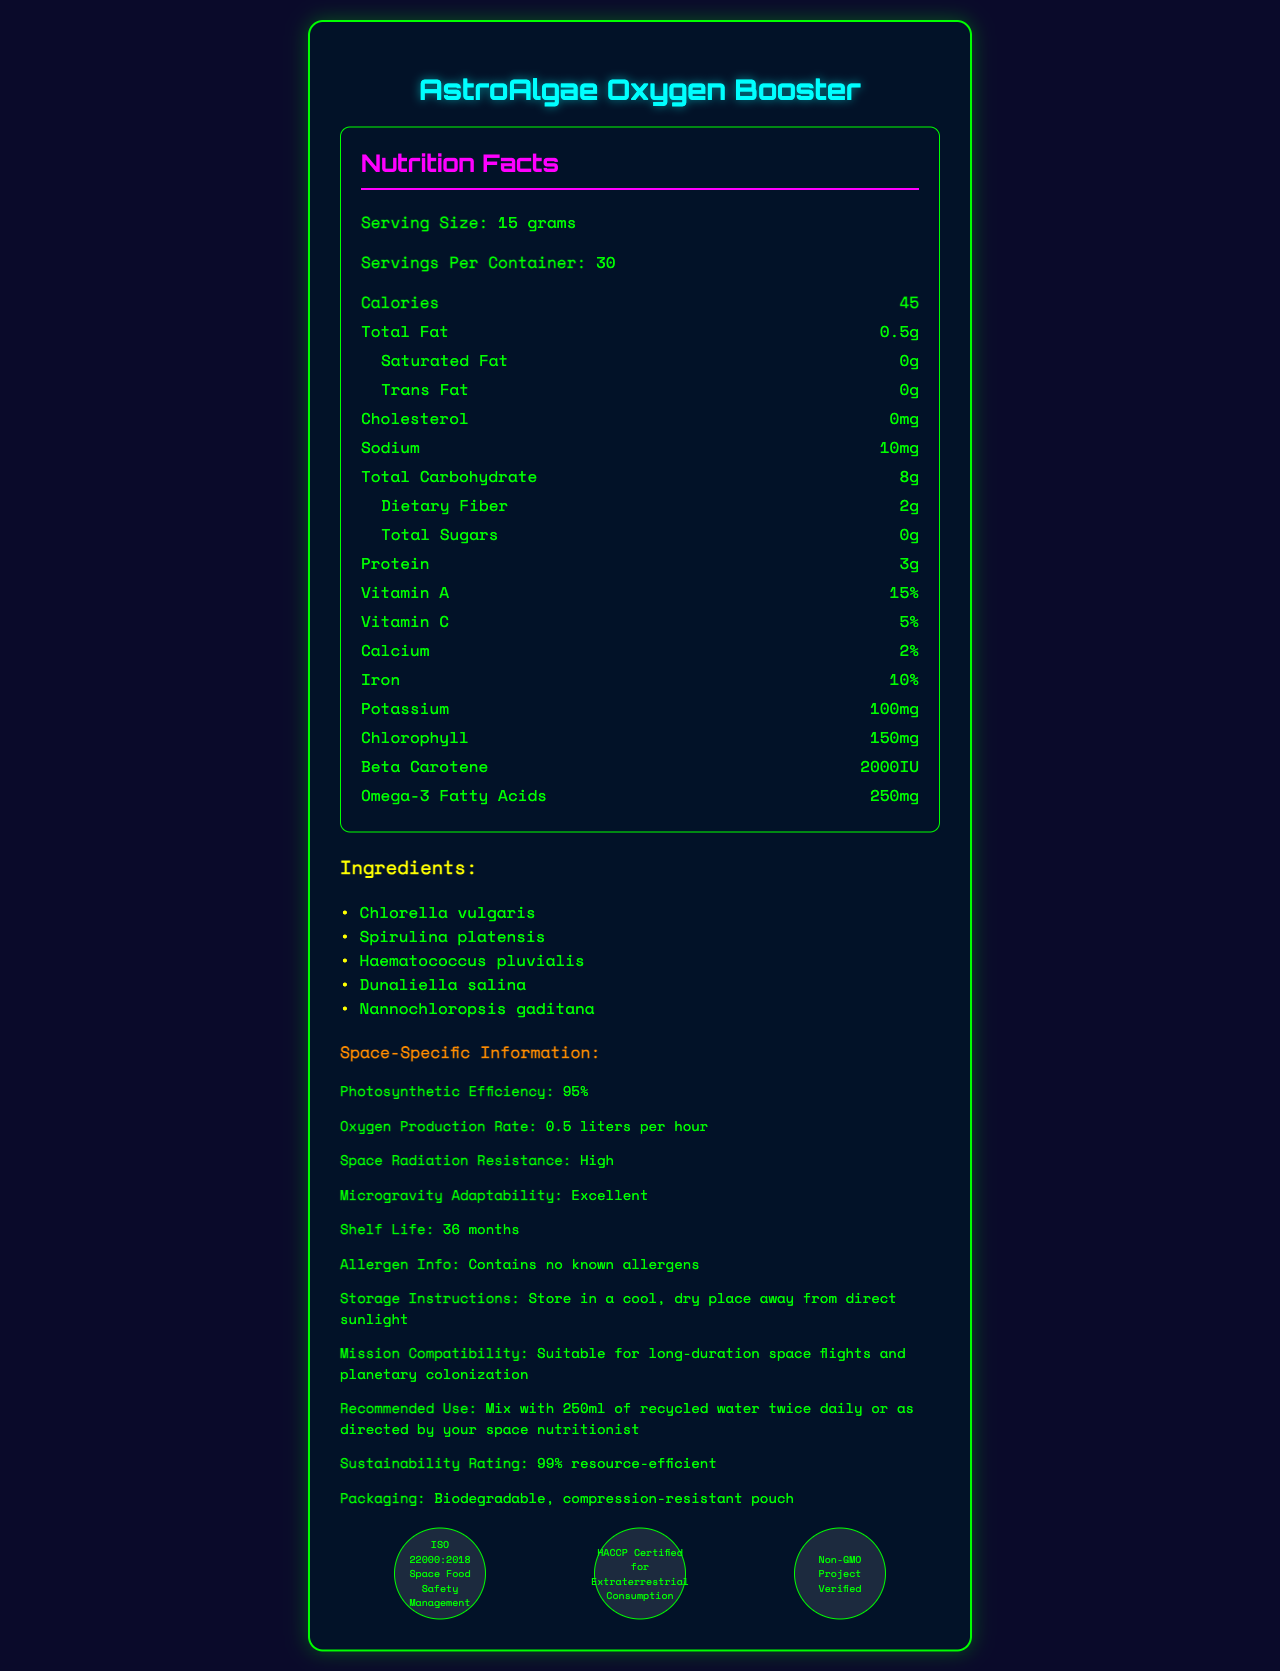What is the serving size of the AstroAlgae Oxygen Booster? The document lists the serving size as 15 grams under the nutrition facts section.
Answer: 15 grams How many servings are there per container? The document states that a container consists of 30 servings.
Answer: 30 servings How much protein is in one serving? According to the nutrition facts, one serving contains 3 grams of protein.
Answer: 3 grams How many calories are in one serving of the supplement? The nutrition facts indicate that there are 45 calories per serving.
Answer: 45 calories What is the total carbohydrate content in one serving? The document lists the total carbohydrate content as 8 grams per serving.
Answer: 8 grams Which of the following is an ingredient in the AstroAlgae Oxygen Booster? A. Chlorella pyrenoidosa B. Spirulina platensis C. Isochrysis galbana D. Euglena gracilis The document lists Spirulina platensis as one of the ingredients.
Answer: B. Spirulina platensis What is the store instruction for the AstroAlgae Oxygen Booster? The document provides storage instructions which specify storing in a cool, dry place away from direct sunlight.
Answer: Store in a cool, dry place away from direct sunlight How much Omega-3 Fatty Acids are present per serving? The nutrition facts specify that each serving contains 250 mg of Omega-3 Fatty Acids.
Answer: 250 mg Which certification does the AstroAlgae Oxygen Booster not have? A. ISO 22000:2018 B. HACCP C. Non-GMO D. FDA Approved The document lists ISO 22000:2018, HACCP, and Non-GMO but does not mention FDA approval.
Answer: D. FDA Approved Is the product suitable for long-duration space flights? The document mentions that the AstroAlgae Oxygen Booster is suitable for long-duration space flights and planetary colonization.
Answer: Yes Describe the main idea of the document. The document describes the nutritional profile and specialized features of the AstroAlgae Oxygen Booster, emphasizing its benefits for space missions.
Answer: The document provides comprehensive information on the AstroAlgae Oxygen Booster, including its nutritional content, ingredients, usage recommendations, space-specific attributes, storage instructions, sustainability rating, packaging details, and certifications. Does the AstroAlgae Oxygen Booster contain any allergens? The document explicitly states that the supplement contains no known allergens.
Answer: No What is the sustainability rating of the product? The document lists a sustainability rating of 99% resource-efficient.
Answer: 99% resource-efficient How much saturated fat is in the supplement? The nutrition section of the document indicates that the supplement contains 0 grams of saturated fat.
Answer: 0 grams What is the photosynthetic efficiency of the AstroAlgae Oxygen Booster? The document specifies that the photosynthetic efficiency of the product is 95%.
Answer: 95% What percentage of daily Vitamin A does each serving provide? The nutrition facts state that one serving provides 15% of the daily recommended intake of Vitamin A.
Answer: 15% What is the iron content in one serving of the supplement? From the nutrition facts, one serving contains 10% of the daily recommended intake of iron.
Answer: 10% How adaptable is the supplement to microgravity? The document mentions that the supplement has excellent adaptability to microgravity conditions.
Answer: Excellent What is the beta carotene content per serving? The nutrition facts list the beta carotene content as 2000 IU per serving.
Answer: 2000 IU How is the product recommended to be used? The document advises this method of use under the recommended use section.
Answer: Mix with 250ml of recycled water twice daily or as directed by your space nutritionist What are the additional benefits of the AstroAlgae Oxygen Booster? The document lists these benefits under the additional benefits section.
Answer: Supports immune function in microgravity, aids in space radiation protection, promotes cardiovascular health during extended space travel, enhances cognitive performance in isolated environments What is the cholesterol content per serving in the supplement? The document specifies that the cholesterol content per serving is 0 mg.
Answer: 0 mg What is the shelf life of the AstroAlgae Oxygen Booster? The document mentions a shelf life of 36 months.
Answer: 36 months Provide three other ingredients found in the AstroAlgae Oxygen Booster aside from Spirulina platensis. The document lists Chlorella vulgaris, Haematococcus pluvialis, and Dunaliella salina among the ingredients.
Answer: Chlorella vulgaris, Haematococcus pluvialis, and Dunaliella salina How many calories from fat are there per serving? The document lists the total fat and calorie content but does not provide specific details on calories from fat.
Answer: Cannot be determined 